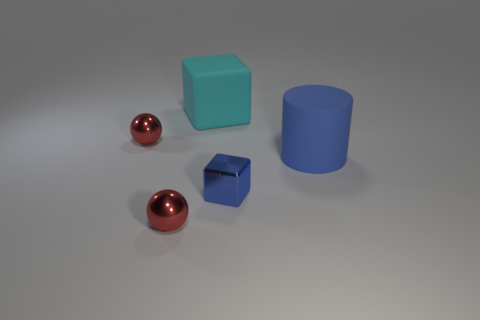Add 5 red metal balls. How many objects exist? 10 Subtract all blocks. How many objects are left? 3 Subtract 0 purple cylinders. How many objects are left? 5 Subtract all big purple metal cylinders. Subtract all blue rubber things. How many objects are left? 4 Add 4 small blocks. How many small blocks are left? 5 Add 5 small blue blocks. How many small blue blocks exist? 6 